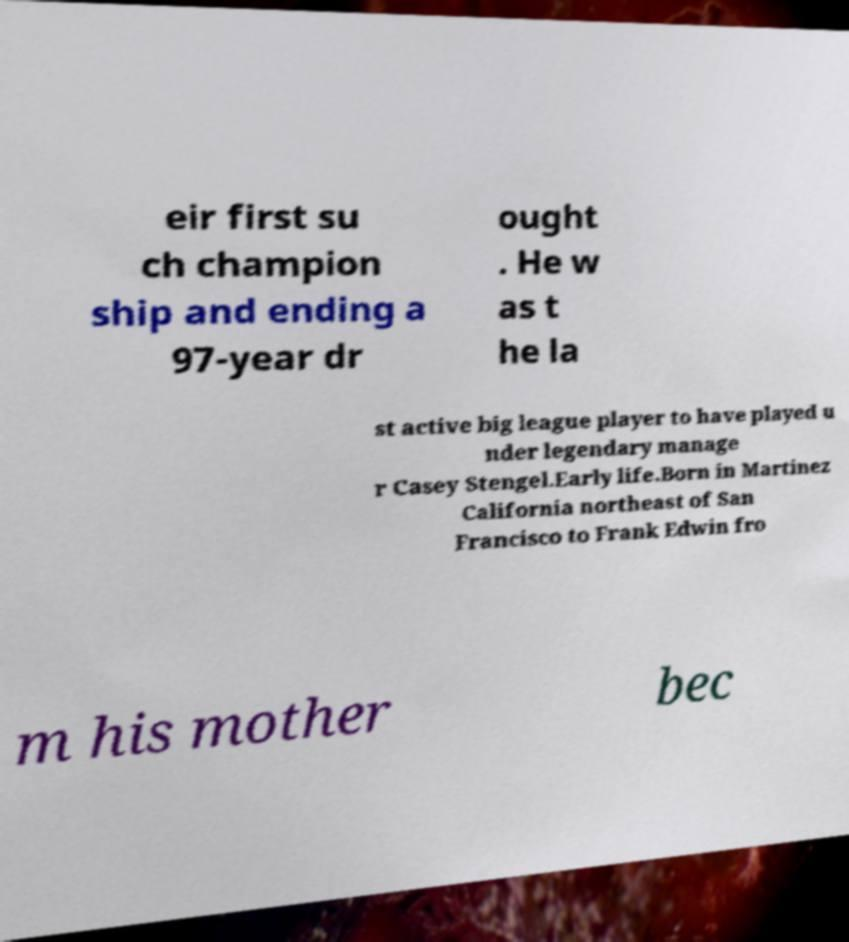Please read and relay the text visible in this image. What does it say? eir first su ch champion ship and ending a 97-year dr ought . He w as t he la st active big league player to have played u nder legendary manage r Casey Stengel.Early life.Born in Martinez California northeast of San Francisco to Frank Edwin fro m his mother bec 